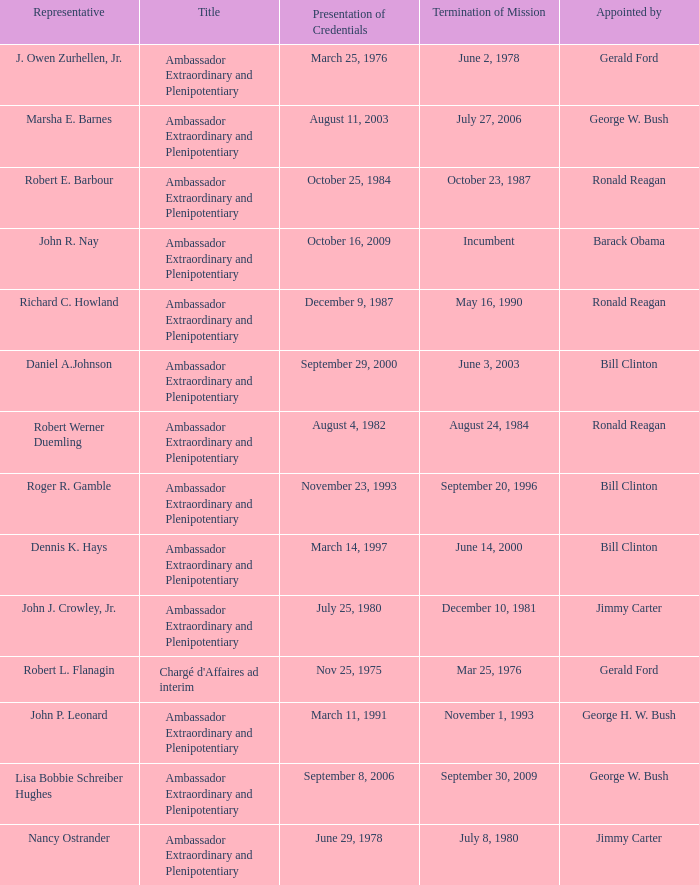Which representative has a Termination of MIssion date Mar 25, 1976? Robert L. Flanagin. 